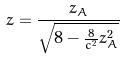Convert formula to latex. <formula><loc_0><loc_0><loc_500><loc_500>z = \frac { z _ { A } } { \sqrt { 8 - \frac { 8 } { c ^ { 2 } } z _ { A } ^ { 2 } } }</formula> 